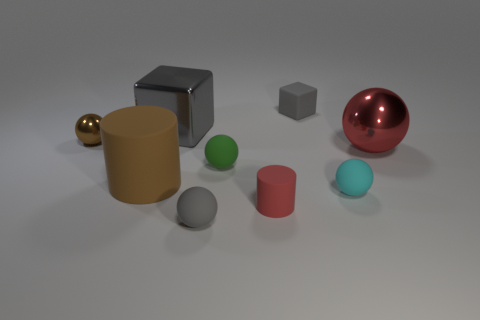Subtract all brown spheres. How many spheres are left? 4 Subtract all cyan spheres. How many spheres are left? 4 Subtract all brown balls. Subtract all blue cylinders. How many balls are left? 4 Subtract all cylinders. How many objects are left? 7 Add 6 large gray blocks. How many large gray blocks exist? 7 Subtract 1 green spheres. How many objects are left? 8 Subtract all brown cubes. Subtract all tiny gray matte objects. How many objects are left? 7 Add 3 tiny red objects. How many tiny red objects are left? 4 